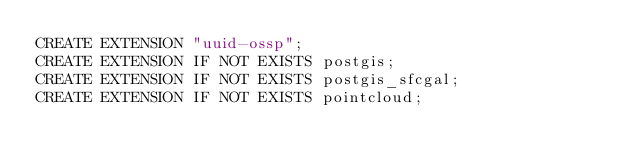<code> <loc_0><loc_0><loc_500><loc_500><_SQL_>CREATE EXTENSION "uuid-ossp";
CREATE EXTENSION IF NOT EXISTS postgis;
CREATE EXTENSION IF NOT EXISTS postgis_sfcgal;
CREATE EXTENSION IF NOT EXISTS pointcloud;</code> 